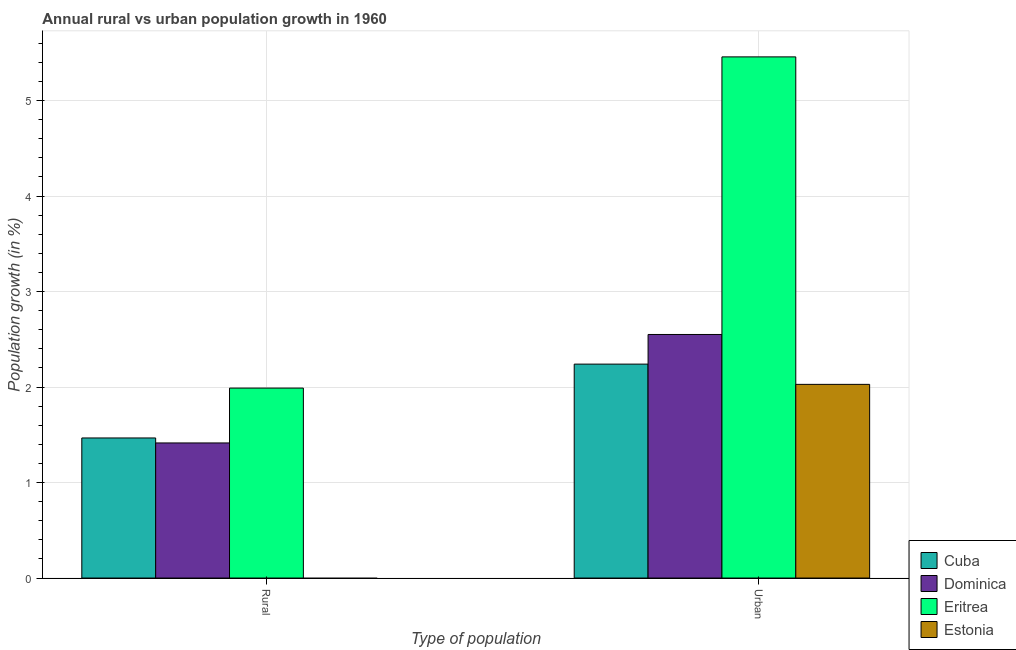Are the number of bars per tick equal to the number of legend labels?
Provide a short and direct response. No. How many bars are there on the 1st tick from the right?
Make the answer very short. 4. What is the label of the 2nd group of bars from the left?
Your answer should be compact. Urban . What is the urban population growth in Dominica?
Your answer should be compact. 2.55. Across all countries, what is the maximum urban population growth?
Ensure brevity in your answer.  5.46. Across all countries, what is the minimum urban population growth?
Make the answer very short. 2.03. In which country was the urban population growth maximum?
Your answer should be very brief. Eritrea. What is the total rural population growth in the graph?
Offer a terse response. 4.87. What is the difference between the urban population growth in Eritrea and that in Dominica?
Your answer should be compact. 2.91. What is the difference between the urban population growth in Dominica and the rural population growth in Eritrea?
Keep it short and to the point. 0.56. What is the average rural population growth per country?
Give a very brief answer. 1.22. What is the difference between the urban population growth and rural population growth in Dominica?
Make the answer very short. 1.14. In how many countries, is the urban population growth greater than 0.8 %?
Ensure brevity in your answer.  4. What is the ratio of the urban population growth in Dominica to that in Eritrea?
Provide a short and direct response. 0.47. Is the urban population growth in Cuba less than that in Dominica?
Your answer should be compact. Yes. In how many countries, is the urban population growth greater than the average urban population growth taken over all countries?
Offer a very short reply. 1. How many bars are there?
Provide a short and direct response. 7. What is the difference between two consecutive major ticks on the Y-axis?
Your answer should be very brief. 1. Does the graph contain any zero values?
Keep it short and to the point. Yes. Does the graph contain grids?
Make the answer very short. Yes. How many legend labels are there?
Keep it short and to the point. 4. What is the title of the graph?
Your answer should be very brief. Annual rural vs urban population growth in 1960. What is the label or title of the X-axis?
Give a very brief answer. Type of population. What is the label or title of the Y-axis?
Offer a very short reply. Population growth (in %). What is the Population growth (in %) of Cuba in Rural?
Make the answer very short. 1.47. What is the Population growth (in %) in Dominica in Rural?
Ensure brevity in your answer.  1.41. What is the Population growth (in %) of Eritrea in Rural?
Your response must be concise. 1.99. What is the Population growth (in %) of Estonia in Rural?
Your answer should be compact. 0. What is the Population growth (in %) of Cuba in Urban ?
Your response must be concise. 2.24. What is the Population growth (in %) in Dominica in Urban ?
Offer a terse response. 2.55. What is the Population growth (in %) in Eritrea in Urban ?
Your response must be concise. 5.46. What is the Population growth (in %) in Estonia in Urban ?
Make the answer very short. 2.03. Across all Type of population, what is the maximum Population growth (in %) in Cuba?
Offer a terse response. 2.24. Across all Type of population, what is the maximum Population growth (in %) of Dominica?
Offer a very short reply. 2.55. Across all Type of population, what is the maximum Population growth (in %) of Eritrea?
Your answer should be very brief. 5.46. Across all Type of population, what is the maximum Population growth (in %) in Estonia?
Provide a short and direct response. 2.03. Across all Type of population, what is the minimum Population growth (in %) of Cuba?
Make the answer very short. 1.47. Across all Type of population, what is the minimum Population growth (in %) of Dominica?
Your answer should be very brief. 1.41. Across all Type of population, what is the minimum Population growth (in %) of Eritrea?
Your response must be concise. 1.99. Across all Type of population, what is the minimum Population growth (in %) in Estonia?
Offer a terse response. 0. What is the total Population growth (in %) in Cuba in the graph?
Make the answer very short. 3.71. What is the total Population growth (in %) of Dominica in the graph?
Offer a terse response. 3.97. What is the total Population growth (in %) in Eritrea in the graph?
Make the answer very short. 7.45. What is the total Population growth (in %) in Estonia in the graph?
Offer a very short reply. 2.03. What is the difference between the Population growth (in %) of Cuba in Rural and that in Urban ?
Give a very brief answer. -0.77. What is the difference between the Population growth (in %) in Dominica in Rural and that in Urban ?
Give a very brief answer. -1.14. What is the difference between the Population growth (in %) of Eritrea in Rural and that in Urban ?
Your answer should be very brief. -3.47. What is the difference between the Population growth (in %) of Cuba in Rural and the Population growth (in %) of Dominica in Urban?
Provide a short and direct response. -1.08. What is the difference between the Population growth (in %) in Cuba in Rural and the Population growth (in %) in Eritrea in Urban?
Provide a succinct answer. -3.99. What is the difference between the Population growth (in %) in Cuba in Rural and the Population growth (in %) in Estonia in Urban?
Ensure brevity in your answer.  -0.56. What is the difference between the Population growth (in %) in Dominica in Rural and the Population growth (in %) in Eritrea in Urban?
Provide a succinct answer. -4.04. What is the difference between the Population growth (in %) in Dominica in Rural and the Population growth (in %) in Estonia in Urban?
Offer a very short reply. -0.61. What is the difference between the Population growth (in %) of Eritrea in Rural and the Population growth (in %) of Estonia in Urban?
Your answer should be compact. -0.04. What is the average Population growth (in %) of Cuba per Type of population?
Make the answer very short. 1.85. What is the average Population growth (in %) of Dominica per Type of population?
Ensure brevity in your answer.  1.98. What is the average Population growth (in %) in Eritrea per Type of population?
Keep it short and to the point. 3.72. What is the difference between the Population growth (in %) in Cuba and Population growth (in %) in Dominica in Rural?
Provide a short and direct response. 0.05. What is the difference between the Population growth (in %) in Cuba and Population growth (in %) in Eritrea in Rural?
Offer a very short reply. -0.52. What is the difference between the Population growth (in %) in Dominica and Population growth (in %) in Eritrea in Rural?
Keep it short and to the point. -0.57. What is the difference between the Population growth (in %) in Cuba and Population growth (in %) in Dominica in Urban ?
Provide a short and direct response. -0.31. What is the difference between the Population growth (in %) of Cuba and Population growth (in %) of Eritrea in Urban ?
Your response must be concise. -3.22. What is the difference between the Population growth (in %) in Cuba and Population growth (in %) in Estonia in Urban ?
Your answer should be very brief. 0.21. What is the difference between the Population growth (in %) in Dominica and Population growth (in %) in Eritrea in Urban ?
Make the answer very short. -2.91. What is the difference between the Population growth (in %) of Dominica and Population growth (in %) of Estonia in Urban ?
Provide a short and direct response. 0.52. What is the difference between the Population growth (in %) of Eritrea and Population growth (in %) of Estonia in Urban ?
Give a very brief answer. 3.43. What is the ratio of the Population growth (in %) in Cuba in Rural to that in Urban ?
Your answer should be compact. 0.65. What is the ratio of the Population growth (in %) in Dominica in Rural to that in Urban ?
Make the answer very short. 0.55. What is the ratio of the Population growth (in %) of Eritrea in Rural to that in Urban ?
Offer a terse response. 0.36. What is the difference between the highest and the second highest Population growth (in %) of Cuba?
Offer a terse response. 0.77. What is the difference between the highest and the second highest Population growth (in %) in Dominica?
Provide a short and direct response. 1.14. What is the difference between the highest and the second highest Population growth (in %) in Eritrea?
Offer a very short reply. 3.47. What is the difference between the highest and the lowest Population growth (in %) in Cuba?
Your answer should be compact. 0.77. What is the difference between the highest and the lowest Population growth (in %) in Dominica?
Make the answer very short. 1.14. What is the difference between the highest and the lowest Population growth (in %) in Eritrea?
Your answer should be very brief. 3.47. What is the difference between the highest and the lowest Population growth (in %) in Estonia?
Offer a very short reply. 2.03. 